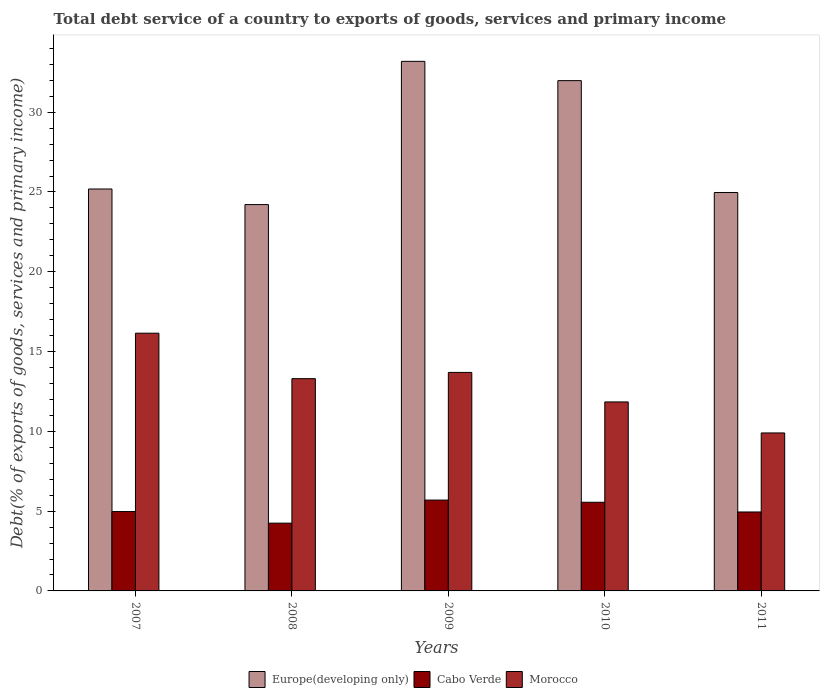How many groups of bars are there?
Give a very brief answer. 5. Are the number of bars per tick equal to the number of legend labels?
Provide a short and direct response. Yes. How many bars are there on the 2nd tick from the right?
Give a very brief answer. 3. In how many cases, is the number of bars for a given year not equal to the number of legend labels?
Give a very brief answer. 0. What is the total debt service in Europe(developing only) in 2008?
Make the answer very short. 24.21. Across all years, what is the maximum total debt service in Morocco?
Offer a terse response. 16.15. Across all years, what is the minimum total debt service in Europe(developing only)?
Ensure brevity in your answer.  24.21. In which year was the total debt service in Europe(developing only) maximum?
Offer a very short reply. 2009. In which year was the total debt service in Cabo Verde minimum?
Your answer should be compact. 2008. What is the total total debt service in Morocco in the graph?
Your response must be concise. 64.89. What is the difference between the total debt service in Cabo Verde in 2008 and that in 2009?
Your answer should be compact. -1.45. What is the difference between the total debt service in Morocco in 2011 and the total debt service in Cabo Verde in 2009?
Give a very brief answer. 4.21. What is the average total debt service in Morocco per year?
Your response must be concise. 12.98. In the year 2010, what is the difference between the total debt service in Europe(developing only) and total debt service in Morocco?
Provide a succinct answer. 20.13. What is the ratio of the total debt service in Morocco in 2007 to that in 2009?
Provide a succinct answer. 1.18. Is the total debt service in Cabo Verde in 2009 less than that in 2011?
Keep it short and to the point. No. Is the difference between the total debt service in Europe(developing only) in 2008 and 2010 greater than the difference between the total debt service in Morocco in 2008 and 2010?
Your answer should be compact. No. What is the difference between the highest and the second highest total debt service in Cabo Verde?
Offer a terse response. 0.14. What is the difference between the highest and the lowest total debt service in Europe(developing only)?
Provide a succinct answer. 8.98. Is the sum of the total debt service in Europe(developing only) in 2007 and 2008 greater than the maximum total debt service in Morocco across all years?
Your answer should be very brief. Yes. What does the 2nd bar from the left in 2009 represents?
Offer a very short reply. Cabo Verde. What does the 2nd bar from the right in 2009 represents?
Offer a terse response. Cabo Verde. Is it the case that in every year, the sum of the total debt service in Morocco and total debt service in Cabo Verde is greater than the total debt service in Europe(developing only)?
Provide a succinct answer. No. How many bars are there?
Make the answer very short. 15. How many years are there in the graph?
Provide a succinct answer. 5. What is the difference between two consecutive major ticks on the Y-axis?
Your answer should be compact. 5. Where does the legend appear in the graph?
Ensure brevity in your answer.  Bottom center. How many legend labels are there?
Your response must be concise. 3. How are the legend labels stacked?
Provide a succinct answer. Horizontal. What is the title of the graph?
Provide a succinct answer. Total debt service of a country to exports of goods, services and primary income. Does "European Union" appear as one of the legend labels in the graph?
Offer a very short reply. No. What is the label or title of the X-axis?
Provide a short and direct response. Years. What is the label or title of the Y-axis?
Ensure brevity in your answer.  Debt(% of exports of goods, services and primary income). What is the Debt(% of exports of goods, services and primary income) in Europe(developing only) in 2007?
Your answer should be compact. 25.19. What is the Debt(% of exports of goods, services and primary income) in Cabo Verde in 2007?
Give a very brief answer. 4.97. What is the Debt(% of exports of goods, services and primary income) in Morocco in 2007?
Your answer should be very brief. 16.15. What is the Debt(% of exports of goods, services and primary income) in Europe(developing only) in 2008?
Your answer should be compact. 24.21. What is the Debt(% of exports of goods, services and primary income) in Cabo Verde in 2008?
Keep it short and to the point. 4.25. What is the Debt(% of exports of goods, services and primary income) in Morocco in 2008?
Offer a very short reply. 13.3. What is the Debt(% of exports of goods, services and primary income) in Europe(developing only) in 2009?
Your answer should be compact. 33.19. What is the Debt(% of exports of goods, services and primary income) of Cabo Verde in 2009?
Your answer should be compact. 5.69. What is the Debt(% of exports of goods, services and primary income) in Morocco in 2009?
Your response must be concise. 13.69. What is the Debt(% of exports of goods, services and primary income) of Europe(developing only) in 2010?
Your answer should be very brief. 31.98. What is the Debt(% of exports of goods, services and primary income) in Cabo Verde in 2010?
Offer a very short reply. 5.56. What is the Debt(% of exports of goods, services and primary income) in Morocco in 2010?
Give a very brief answer. 11.84. What is the Debt(% of exports of goods, services and primary income) in Europe(developing only) in 2011?
Your answer should be compact. 24.97. What is the Debt(% of exports of goods, services and primary income) in Cabo Verde in 2011?
Offer a terse response. 4.95. What is the Debt(% of exports of goods, services and primary income) in Morocco in 2011?
Your answer should be very brief. 9.9. Across all years, what is the maximum Debt(% of exports of goods, services and primary income) of Europe(developing only)?
Give a very brief answer. 33.19. Across all years, what is the maximum Debt(% of exports of goods, services and primary income) of Cabo Verde?
Your answer should be very brief. 5.69. Across all years, what is the maximum Debt(% of exports of goods, services and primary income) of Morocco?
Make the answer very short. 16.15. Across all years, what is the minimum Debt(% of exports of goods, services and primary income) of Europe(developing only)?
Provide a short and direct response. 24.21. Across all years, what is the minimum Debt(% of exports of goods, services and primary income) of Cabo Verde?
Ensure brevity in your answer.  4.25. Across all years, what is the minimum Debt(% of exports of goods, services and primary income) in Morocco?
Your answer should be very brief. 9.9. What is the total Debt(% of exports of goods, services and primary income) in Europe(developing only) in the graph?
Your answer should be very brief. 139.53. What is the total Debt(% of exports of goods, services and primary income) in Cabo Verde in the graph?
Your answer should be very brief. 25.42. What is the total Debt(% of exports of goods, services and primary income) of Morocco in the graph?
Ensure brevity in your answer.  64.89. What is the difference between the Debt(% of exports of goods, services and primary income) in Europe(developing only) in 2007 and that in 2008?
Provide a succinct answer. 0.98. What is the difference between the Debt(% of exports of goods, services and primary income) of Cabo Verde in 2007 and that in 2008?
Provide a succinct answer. 0.73. What is the difference between the Debt(% of exports of goods, services and primary income) of Morocco in 2007 and that in 2008?
Give a very brief answer. 2.85. What is the difference between the Debt(% of exports of goods, services and primary income) of Europe(developing only) in 2007 and that in 2009?
Your answer should be compact. -8. What is the difference between the Debt(% of exports of goods, services and primary income) in Cabo Verde in 2007 and that in 2009?
Make the answer very short. -0.72. What is the difference between the Debt(% of exports of goods, services and primary income) of Morocco in 2007 and that in 2009?
Offer a very short reply. 2.46. What is the difference between the Debt(% of exports of goods, services and primary income) in Europe(developing only) in 2007 and that in 2010?
Keep it short and to the point. -6.79. What is the difference between the Debt(% of exports of goods, services and primary income) in Cabo Verde in 2007 and that in 2010?
Your answer should be compact. -0.58. What is the difference between the Debt(% of exports of goods, services and primary income) in Morocco in 2007 and that in 2010?
Your response must be concise. 4.31. What is the difference between the Debt(% of exports of goods, services and primary income) in Europe(developing only) in 2007 and that in 2011?
Give a very brief answer. 0.22. What is the difference between the Debt(% of exports of goods, services and primary income) of Cabo Verde in 2007 and that in 2011?
Your answer should be compact. 0.03. What is the difference between the Debt(% of exports of goods, services and primary income) in Morocco in 2007 and that in 2011?
Ensure brevity in your answer.  6.25. What is the difference between the Debt(% of exports of goods, services and primary income) of Europe(developing only) in 2008 and that in 2009?
Give a very brief answer. -8.98. What is the difference between the Debt(% of exports of goods, services and primary income) of Cabo Verde in 2008 and that in 2009?
Offer a very short reply. -1.45. What is the difference between the Debt(% of exports of goods, services and primary income) of Morocco in 2008 and that in 2009?
Your response must be concise. -0.39. What is the difference between the Debt(% of exports of goods, services and primary income) of Europe(developing only) in 2008 and that in 2010?
Keep it short and to the point. -7.77. What is the difference between the Debt(% of exports of goods, services and primary income) of Cabo Verde in 2008 and that in 2010?
Offer a terse response. -1.31. What is the difference between the Debt(% of exports of goods, services and primary income) in Morocco in 2008 and that in 2010?
Your answer should be very brief. 1.46. What is the difference between the Debt(% of exports of goods, services and primary income) of Europe(developing only) in 2008 and that in 2011?
Keep it short and to the point. -0.76. What is the difference between the Debt(% of exports of goods, services and primary income) of Cabo Verde in 2008 and that in 2011?
Provide a succinct answer. -0.7. What is the difference between the Debt(% of exports of goods, services and primary income) of Morocco in 2008 and that in 2011?
Give a very brief answer. 3.4. What is the difference between the Debt(% of exports of goods, services and primary income) in Europe(developing only) in 2009 and that in 2010?
Your response must be concise. 1.21. What is the difference between the Debt(% of exports of goods, services and primary income) in Cabo Verde in 2009 and that in 2010?
Your answer should be very brief. 0.14. What is the difference between the Debt(% of exports of goods, services and primary income) in Morocco in 2009 and that in 2010?
Make the answer very short. 1.85. What is the difference between the Debt(% of exports of goods, services and primary income) of Europe(developing only) in 2009 and that in 2011?
Offer a very short reply. 8.22. What is the difference between the Debt(% of exports of goods, services and primary income) of Cabo Verde in 2009 and that in 2011?
Your response must be concise. 0.75. What is the difference between the Debt(% of exports of goods, services and primary income) of Morocco in 2009 and that in 2011?
Give a very brief answer. 3.79. What is the difference between the Debt(% of exports of goods, services and primary income) of Europe(developing only) in 2010 and that in 2011?
Keep it short and to the point. 7.01. What is the difference between the Debt(% of exports of goods, services and primary income) of Cabo Verde in 2010 and that in 2011?
Give a very brief answer. 0.61. What is the difference between the Debt(% of exports of goods, services and primary income) in Morocco in 2010 and that in 2011?
Keep it short and to the point. 1.94. What is the difference between the Debt(% of exports of goods, services and primary income) of Europe(developing only) in 2007 and the Debt(% of exports of goods, services and primary income) of Cabo Verde in 2008?
Make the answer very short. 20.94. What is the difference between the Debt(% of exports of goods, services and primary income) of Europe(developing only) in 2007 and the Debt(% of exports of goods, services and primary income) of Morocco in 2008?
Provide a succinct answer. 11.89. What is the difference between the Debt(% of exports of goods, services and primary income) in Cabo Verde in 2007 and the Debt(% of exports of goods, services and primary income) in Morocco in 2008?
Offer a terse response. -8.33. What is the difference between the Debt(% of exports of goods, services and primary income) in Europe(developing only) in 2007 and the Debt(% of exports of goods, services and primary income) in Cabo Verde in 2009?
Your answer should be very brief. 19.49. What is the difference between the Debt(% of exports of goods, services and primary income) in Europe(developing only) in 2007 and the Debt(% of exports of goods, services and primary income) in Morocco in 2009?
Give a very brief answer. 11.49. What is the difference between the Debt(% of exports of goods, services and primary income) in Cabo Verde in 2007 and the Debt(% of exports of goods, services and primary income) in Morocco in 2009?
Your answer should be compact. -8.72. What is the difference between the Debt(% of exports of goods, services and primary income) in Europe(developing only) in 2007 and the Debt(% of exports of goods, services and primary income) in Cabo Verde in 2010?
Give a very brief answer. 19.63. What is the difference between the Debt(% of exports of goods, services and primary income) in Europe(developing only) in 2007 and the Debt(% of exports of goods, services and primary income) in Morocco in 2010?
Your response must be concise. 13.34. What is the difference between the Debt(% of exports of goods, services and primary income) of Cabo Verde in 2007 and the Debt(% of exports of goods, services and primary income) of Morocco in 2010?
Make the answer very short. -6.87. What is the difference between the Debt(% of exports of goods, services and primary income) in Europe(developing only) in 2007 and the Debt(% of exports of goods, services and primary income) in Cabo Verde in 2011?
Your answer should be very brief. 20.24. What is the difference between the Debt(% of exports of goods, services and primary income) in Europe(developing only) in 2007 and the Debt(% of exports of goods, services and primary income) in Morocco in 2011?
Your answer should be compact. 15.29. What is the difference between the Debt(% of exports of goods, services and primary income) of Cabo Verde in 2007 and the Debt(% of exports of goods, services and primary income) of Morocco in 2011?
Give a very brief answer. -4.92. What is the difference between the Debt(% of exports of goods, services and primary income) in Europe(developing only) in 2008 and the Debt(% of exports of goods, services and primary income) in Cabo Verde in 2009?
Ensure brevity in your answer.  18.52. What is the difference between the Debt(% of exports of goods, services and primary income) in Europe(developing only) in 2008 and the Debt(% of exports of goods, services and primary income) in Morocco in 2009?
Offer a terse response. 10.52. What is the difference between the Debt(% of exports of goods, services and primary income) in Cabo Verde in 2008 and the Debt(% of exports of goods, services and primary income) in Morocco in 2009?
Ensure brevity in your answer.  -9.45. What is the difference between the Debt(% of exports of goods, services and primary income) in Europe(developing only) in 2008 and the Debt(% of exports of goods, services and primary income) in Cabo Verde in 2010?
Make the answer very short. 18.65. What is the difference between the Debt(% of exports of goods, services and primary income) of Europe(developing only) in 2008 and the Debt(% of exports of goods, services and primary income) of Morocco in 2010?
Offer a terse response. 12.37. What is the difference between the Debt(% of exports of goods, services and primary income) in Cabo Verde in 2008 and the Debt(% of exports of goods, services and primary income) in Morocco in 2010?
Your answer should be compact. -7.6. What is the difference between the Debt(% of exports of goods, services and primary income) in Europe(developing only) in 2008 and the Debt(% of exports of goods, services and primary income) in Cabo Verde in 2011?
Make the answer very short. 19.26. What is the difference between the Debt(% of exports of goods, services and primary income) of Europe(developing only) in 2008 and the Debt(% of exports of goods, services and primary income) of Morocco in 2011?
Your answer should be very brief. 14.31. What is the difference between the Debt(% of exports of goods, services and primary income) in Cabo Verde in 2008 and the Debt(% of exports of goods, services and primary income) in Morocco in 2011?
Your answer should be compact. -5.65. What is the difference between the Debt(% of exports of goods, services and primary income) of Europe(developing only) in 2009 and the Debt(% of exports of goods, services and primary income) of Cabo Verde in 2010?
Provide a succinct answer. 27.63. What is the difference between the Debt(% of exports of goods, services and primary income) in Europe(developing only) in 2009 and the Debt(% of exports of goods, services and primary income) in Morocco in 2010?
Provide a short and direct response. 21.34. What is the difference between the Debt(% of exports of goods, services and primary income) in Cabo Verde in 2009 and the Debt(% of exports of goods, services and primary income) in Morocco in 2010?
Offer a terse response. -6.15. What is the difference between the Debt(% of exports of goods, services and primary income) of Europe(developing only) in 2009 and the Debt(% of exports of goods, services and primary income) of Cabo Verde in 2011?
Your answer should be compact. 28.24. What is the difference between the Debt(% of exports of goods, services and primary income) of Europe(developing only) in 2009 and the Debt(% of exports of goods, services and primary income) of Morocco in 2011?
Give a very brief answer. 23.29. What is the difference between the Debt(% of exports of goods, services and primary income) in Cabo Verde in 2009 and the Debt(% of exports of goods, services and primary income) in Morocco in 2011?
Keep it short and to the point. -4.21. What is the difference between the Debt(% of exports of goods, services and primary income) in Europe(developing only) in 2010 and the Debt(% of exports of goods, services and primary income) in Cabo Verde in 2011?
Offer a very short reply. 27.03. What is the difference between the Debt(% of exports of goods, services and primary income) of Europe(developing only) in 2010 and the Debt(% of exports of goods, services and primary income) of Morocco in 2011?
Ensure brevity in your answer.  22.08. What is the difference between the Debt(% of exports of goods, services and primary income) of Cabo Verde in 2010 and the Debt(% of exports of goods, services and primary income) of Morocco in 2011?
Offer a terse response. -4.34. What is the average Debt(% of exports of goods, services and primary income) of Europe(developing only) per year?
Provide a succinct answer. 27.91. What is the average Debt(% of exports of goods, services and primary income) of Cabo Verde per year?
Provide a succinct answer. 5.08. What is the average Debt(% of exports of goods, services and primary income) of Morocco per year?
Your answer should be compact. 12.98. In the year 2007, what is the difference between the Debt(% of exports of goods, services and primary income) of Europe(developing only) and Debt(% of exports of goods, services and primary income) of Cabo Verde?
Give a very brief answer. 20.21. In the year 2007, what is the difference between the Debt(% of exports of goods, services and primary income) in Europe(developing only) and Debt(% of exports of goods, services and primary income) in Morocco?
Offer a very short reply. 9.04. In the year 2007, what is the difference between the Debt(% of exports of goods, services and primary income) of Cabo Verde and Debt(% of exports of goods, services and primary income) of Morocco?
Make the answer very short. -11.18. In the year 2008, what is the difference between the Debt(% of exports of goods, services and primary income) of Europe(developing only) and Debt(% of exports of goods, services and primary income) of Cabo Verde?
Give a very brief answer. 19.96. In the year 2008, what is the difference between the Debt(% of exports of goods, services and primary income) in Europe(developing only) and Debt(% of exports of goods, services and primary income) in Morocco?
Your answer should be very brief. 10.91. In the year 2008, what is the difference between the Debt(% of exports of goods, services and primary income) in Cabo Verde and Debt(% of exports of goods, services and primary income) in Morocco?
Provide a succinct answer. -9.05. In the year 2009, what is the difference between the Debt(% of exports of goods, services and primary income) in Europe(developing only) and Debt(% of exports of goods, services and primary income) in Cabo Verde?
Your answer should be very brief. 27.49. In the year 2009, what is the difference between the Debt(% of exports of goods, services and primary income) of Europe(developing only) and Debt(% of exports of goods, services and primary income) of Morocco?
Ensure brevity in your answer.  19.49. In the year 2009, what is the difference between the Debt(% of exports of goods, services and primary income) in Cabo Verde and Debt(% of exports of goods, services and primary income) in Morocco?
Offer a very short reply. -8. In the year 2010, what is the difference between the Debt(% of exports of goods, services and primary income) of Europe(developing only) and Debt(% of exports of goods, services and primary income) of Cabo Verde?
Ensure brevity in your answer.  26.42. In the year 2010, what is the difference between the Debt(% of exports of goods, services and primary income) in Europe(developing only) and Debt(% of exports of goods, services and primary income) in Morocco?
Offer a very short reply. 20.13. In the year 2010, what is the difference between the Debt(% of exports of goods, services and primary income) in Cabo Verde and Debt(% of exports of goods, services and primary income) in Morocco?
Offer a very short reply. -6.29. In the year 2011, what is the difference between the Debt(% of exports of goods, services and primary income) of Europe(developing only) and Debt(% of exports of goods, services and primary income) of Cabo Verde?
Keep it short and to the point. 20.02. In the year 2011, what is the difference between the Debt(% of exports of goods, services and primary income) of Europe(developing only) and Debt(% of exports of goods, services and primary income) of Morocco?
Provide a short and direct response. 15.07. In the year 2011, what is the difference between the Debt(% of exports of goods, services and primary income) of Cabo Verde and Debt(% of exports of goods, services and primary income) of Morocco?
Make the answer very short. -4.95. What is the ratio of the Debt(% of exports of goods, services and primary income) of Europe(developing only) in 2007 to that in 2008?
Provide a short and direct response. 1.04. What is the ratio of the Debt(% of exports of goods, services and primary income) in Cabo Verde in 2007 to that in 2008?
Provide a succinct answer. 1.17. What is the ratio of the Debt(% of exports of goods, services and primary income) of Morocco in 2007 to that in 2008?
Provide a succinct answer. 1.21. What is the ratio of the Debt(% of exports of goods, services and primary income) of Europe(developing only) in 2007 to that in 2009?
Your answer should be compact. 0.76. What is the ratio of the Debt(% of exports of goods, services and primary income) in Cabo Verde in 2007 to that in 2009?
Offer a terse response. 0.87. What is the ratio of the Debt(% of exports of goods, services and primary income) in Morocco in 2007 to that in 2009?
Give a very brief answer. 1.18. What is the ratio of the Debt(% of exports of goods, services and primary income) of Europe(developing only) in 2007 to that in 2010?
Offer a terse response. 0.79. What is the ratio of the Debt(% of exports of goods, services and primary income) of Cabo Verde in 2007 to that in 2010?
Your answer should be very brief. 0.9. What is the ratio of the Debt(% of exports of goods, services and primary income) of Morocco in 2007 to that in 2010?
Ensure brevity in your answer.  1.36. What is the ratio of the Debt(% of exports of goods, services and primary income) in Europe(developing only) in 2007 to that in 2011?
Keep it short and to the point. 1.01. What is the ratio of the Debt(% of exports of goods, services and primary income) of Cabo Verde in 2007 to that in 2011?
Make the answer very short. 1.01. What is the ratio of the Debt(% of exports of goods, services and primary income) of Morocco in 2007 to that in 2011?
Offer a very short reply. 1.63. What is the ratio of the Debt(% of exports of goods, services and primary income) of Europe(developing only) in 2008 to that in 2009?
Ensure brevity in your answer.  0.73. What is the ratio of the Debt(% of exports of goods, services and primary income) of Cabo Verde in 2008 to that in 2009?
Give a very brief answer. 0.75. What is the ratio of the Debt(% of exports of goods, services and primary income) in Morocco in 2008 to that in 2009?
Ensure brevity in your answer.  0.97. What is the ratio of the Debt(% of exports of goods, services and primary income) in Europe(developing only) in 2008 to that in 2010?
Provide a succinct answer. 0.76. What is the ratio of the Debt(% of exports of goods, services and primary income) of Cabo Verde in 2008 to that in 2010?
Your answer should be compact. 0.76. What is the ratio of the Debt(% of exports of goods, services and primary income) of Morocco in 2008 to that in 2010?
Make the answer very short. 1.12. What is the ratio of the Debt(% of exports of goods, services and primary income) in Europe(developing only) in 2008 to that in 2011?
Provide a short and direct response. 0.97. What is the ratio of the Debt(% of exports of goods, services and primary income) in Cabo Verde in 2008 to that in 2011?
Keep it short and to the point. 0.86. What is the ratio of the Debt(% of exports of goods, services and primary income) in Morocco in 2008 to that in 2011?
Ensure brevity in your answer.  1.34. What is the ratio of the Debt(% of exports of goods, services and primary income) in Europe(developing only) in 2009 to that in 2010?
Give a very brief answer. 1.04. What is the ratio of the Debt(% of exports of goods, services and primary income) of Cabo Verde in 2009 to that in 2010?
Ensure brevity in your answer.  1.02. What is the ratio of the Debt(% of exports of goods, services and primary income) of Morocco in 2009 to that in 2010?
Your answer should be very brief. 1.16. What is the ratio of the Debt(% of exports of goods, services and primary income) in Europe(developing only) in 2009 to that in 2011?
Ensure brevity in your answer.  1.33. What is the ratio of the Debt(% of exports of goods, services and primary income) of Cabo Verde in 2009 to that in 2011?
Ensure brevity in your answer.  1.15. What is the ratio of the Debt(% of exports of goods, services and primary income) of Morocco in 2009 to that in 2011?
Make the answer very short. 1.38. What is the ratio of the Debt(% of exports of goods, services and primary income) in Europe(developing only) in 2010 to that in 2011?
Provide a short and direct response. 1.28. What is the ratio of the Debt(% of exports of goods, services and primary income) of Cabo Verde in 2010 to that in 2011?
Your answer should be very brief. 1.12. What is the ratio of the Debt(% of exports of goods, services and primary income) in Morocco in 2010 to that in 2011?
Offer a terse response. 1.2. What is the difference between the highest and the second highest Debt(% of exports of goods, services and primary income) of Europe(developing only)?
Your response must be concise. 1.21. What is the difference between the highest and the second highest Debt(% of exports of goods, services and primary income) in Cabo Verde?
Provide a short and direct response. 0.14. What is the difference between the highest and the second highest Debt(% of exports of goods, services and primary income) in Morocco?
Your answer should be very brief. 2.46. What is the difference between the highest and the lowest Debt(% of exports of goods, services and primary income) in Europe(developing only)?
Offer a very short reply. 8.98. What is the difference between the highest and the lowest Debt(% of exports of goods, services and primary income) in Cabo Verde?
Give a very brief answer. 1.45. What is the difference between the highest and the lowest Debt(% of exports of goods, services and primary income) of Morocco?
Make the answer very short. 6.25. 